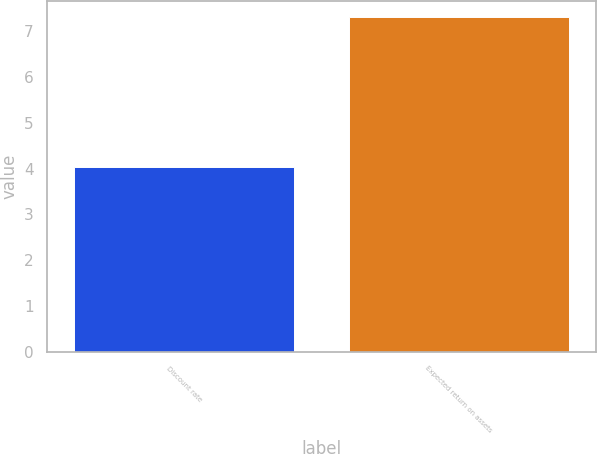<chart> <loc_0><loc_0><loc_500><loc_500><bar_chart><fcel>Discount rate<fcel>Expected return on assets<nl><fcel>4.04<fcel>7.3<nl></chart> 